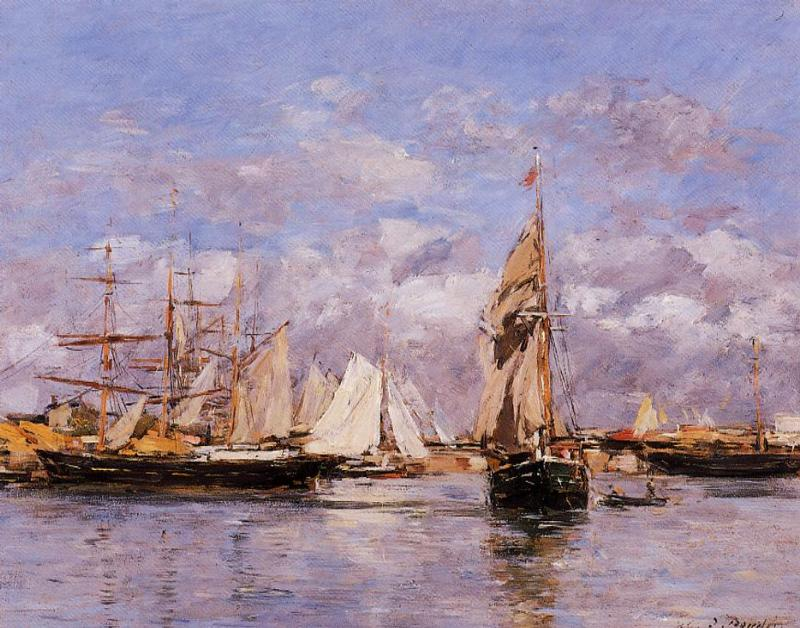Explain the visual content of the image in great detail. This image presents a lively harbor scene, rendered in the impressionist style where brushstrokes and color variations capture the essence of light and atmosphere rather than detailed forms. In the foreground, a dominant sailboat with a billowed, tawny sail captures our attention, anchored near the harbor's edge. Surrounding it are various maritime vessels, including smaller sailboats with crisp white sails and larger, multi-masted ships, hinting at the harbor's bustling activity. The reflections in the water are skillfully suggested with loose brushwork, giving life to the scene's calm yet dynamic setting. In the background, one can see a spread of edifices under a sky where voluminous clouds drift. These buildings convey a sense of a nearby coastal town. The color palette is rich with pastel blues, warm yellows, and gentle pinks, softened by the light permeating the scene, evoking a sense of tranquility despite the harbor's activity. The impressionist style shines through the apparent spontaneity in executing each brushstroke, aiming to convey the sensation of this maritime tableau rather than an exact likeness. It's an artistic dance between reality and its ephemeral impression on the viewer, emblematic of the movement’s intent to encapsulate a moment's fleeting beauty. 